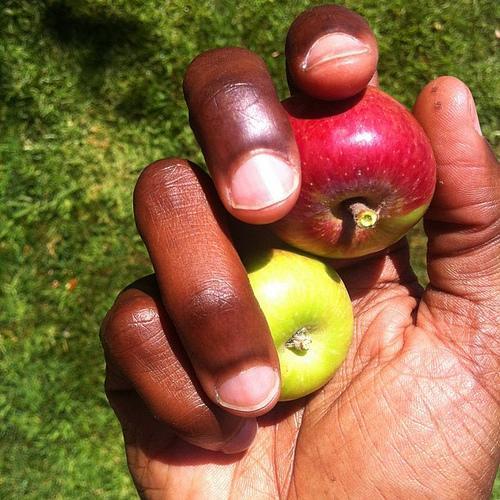How many apples are there?
Give a very brief answer. 2. 